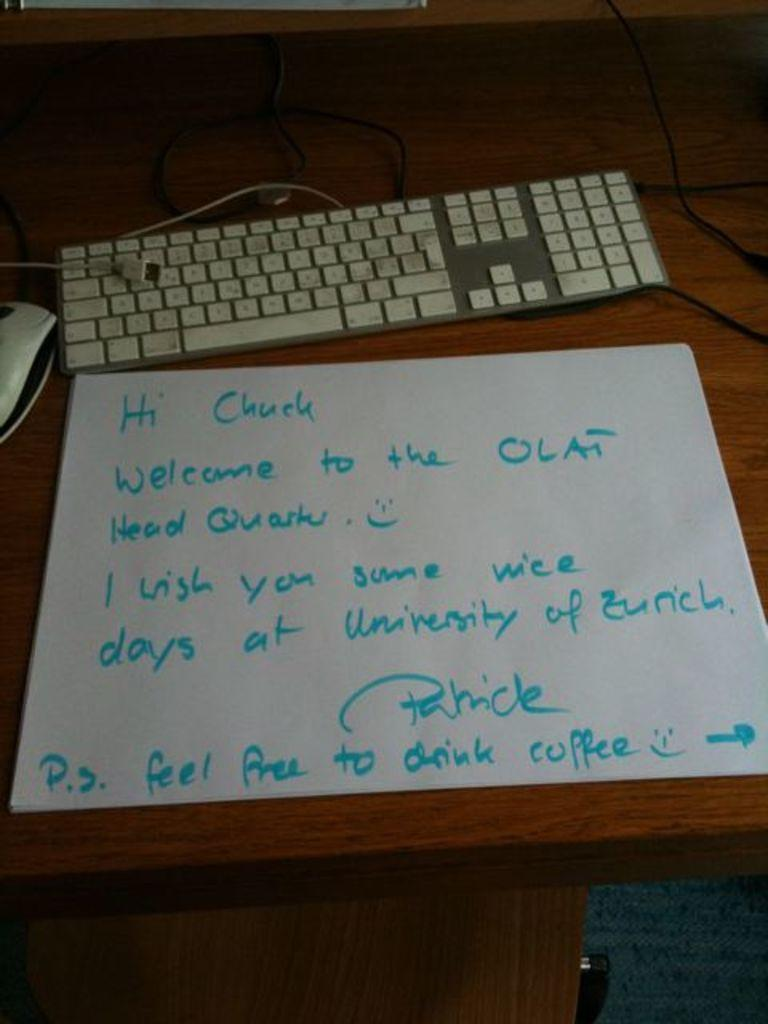<image>
Provide a brief description of the given image. Letter written in blue marker to Chuck sits on a table next to a keyboard. 